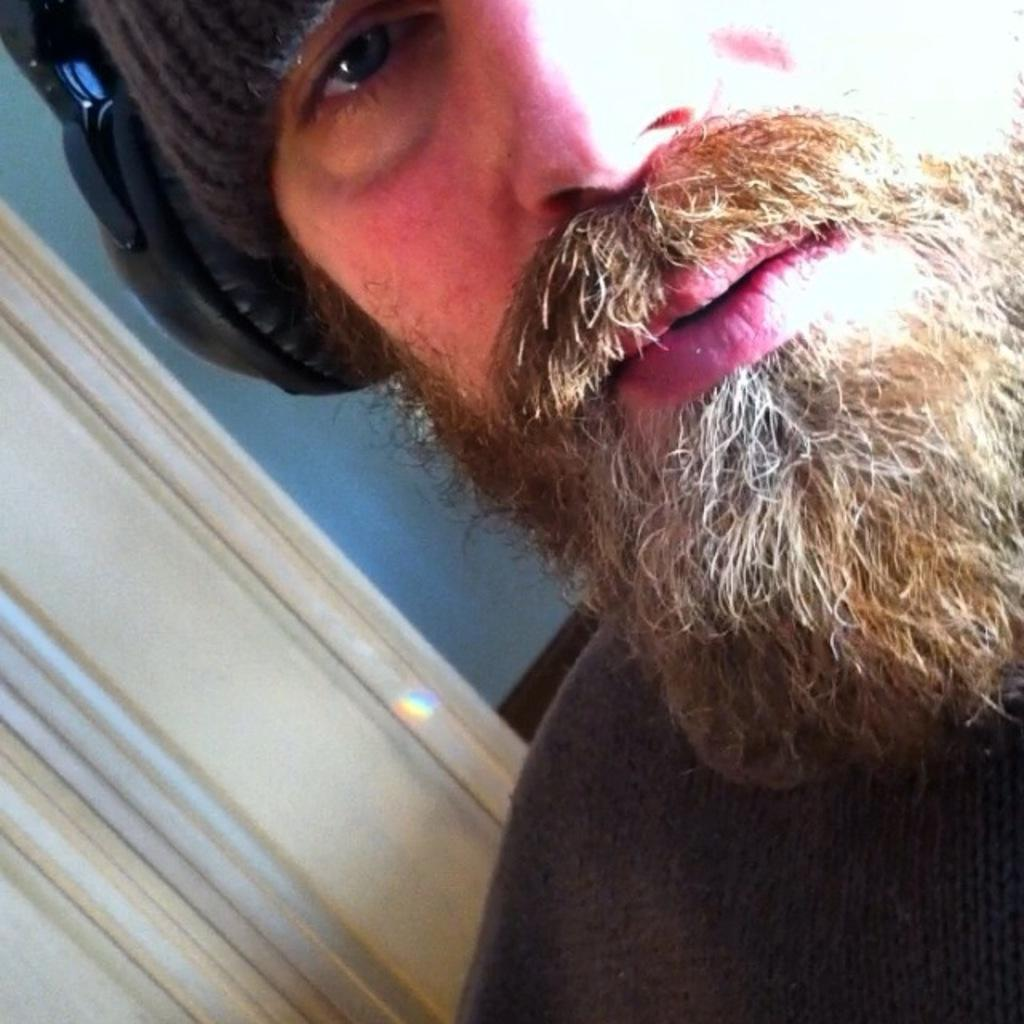What is the main subject in the foreground of the image? There is a man in the foreground of the image. What is the man wearing in the image? The man is wearing a headset in the image. What can be seen in the background of the image? There is a wall in the background of the image. What type of flower can be seen growing on the wall in the image? There are no flowers visible on the wall in the image. What sound do the bells make in the image? There are no bells present in the image. 